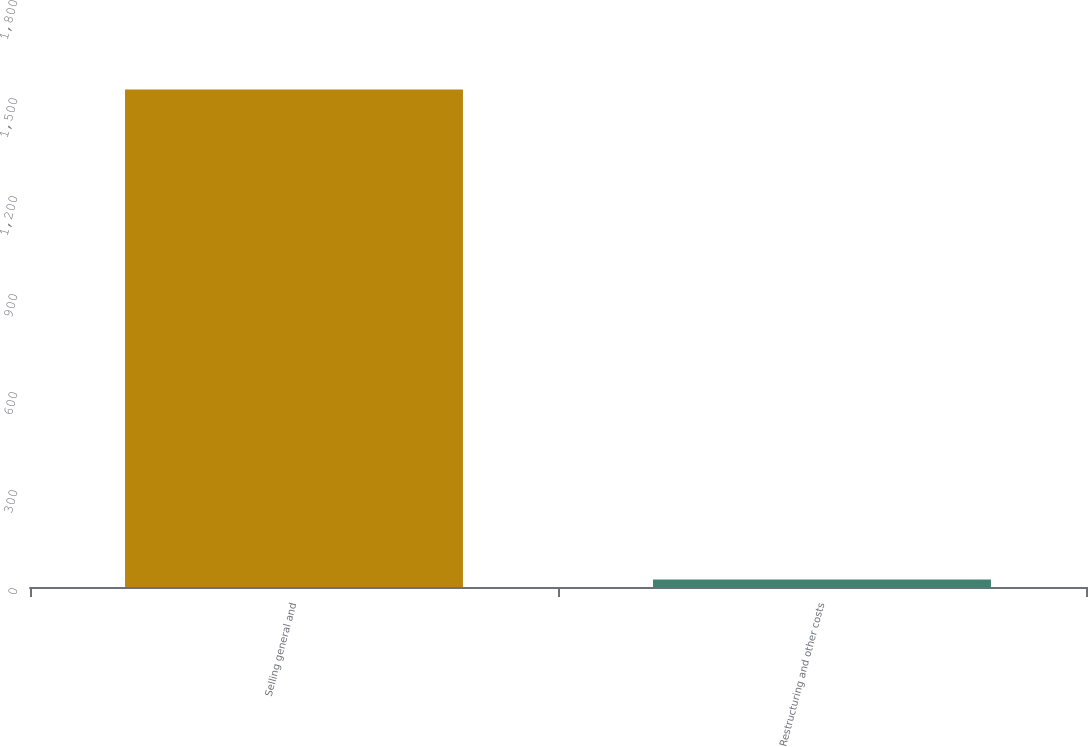<chart> <loc_0><loc_0><loc_500><loc_500><bar_chart><fcel>Selling general and<fcel>Restructuring and other costs<nl><fcel>1523<fcel>23.2<nl></chart> 